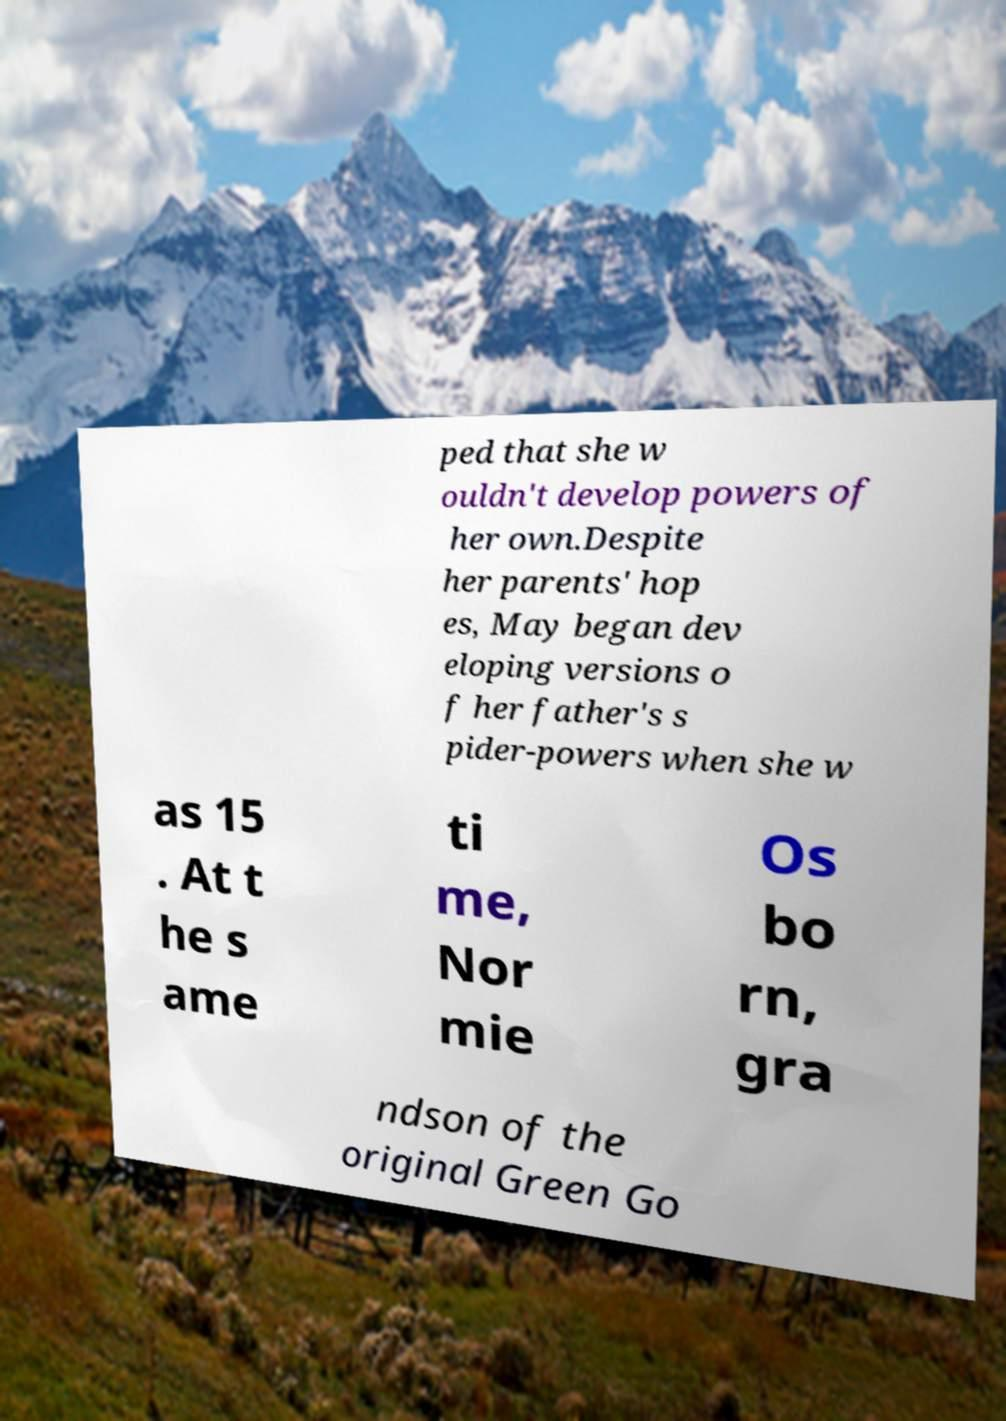Could you assist in decoding the text presented in this image and type it out clearly? ped that she w ouldn't develop powers of her own.Despite her parents' hop es, May began dev eloping versions o f her father's s pider-powers when she w as 15 . At t he s ame ti me, Nor mie Os bo rn, gra ndson of the original Green Go 